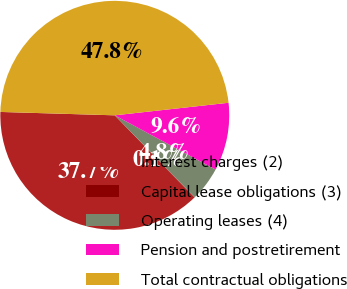Convert chart to OTSL. <chart><loc_0><loc_0><loc_500><loc_500><pie_chart><fcel>Interest charges (2)<fcel>Capital lease obligations (3)<fcel>Operating leases (4)<fcel>Pension and postretirement<fcel>Total contractual obligations<nl><fcel>37.71%<fcel>0.06%<fcel>4.84%<fcel>9.61%<fcel>47.78%<nl></chart> 